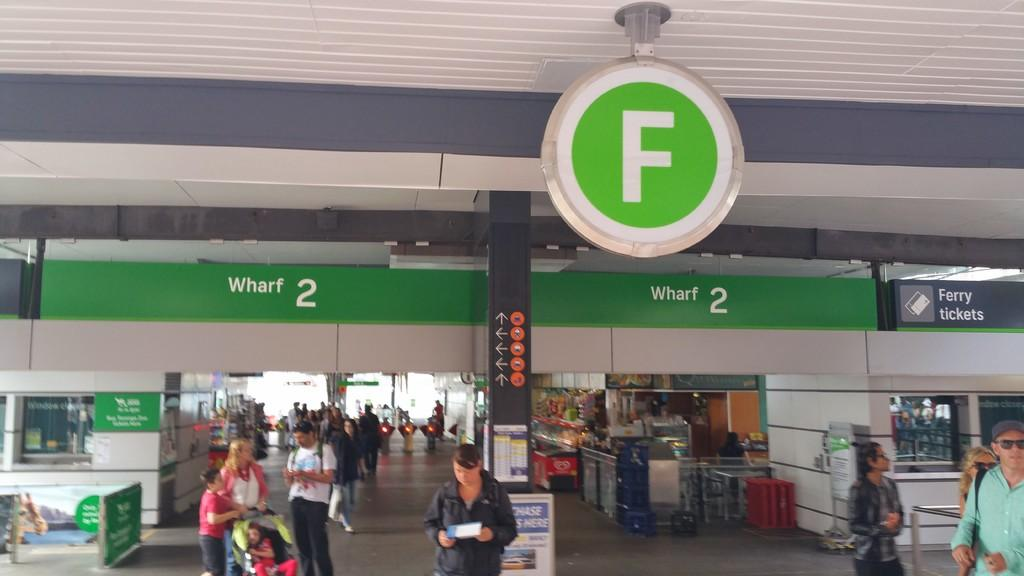<image>
Present a compact description of the photo's key features. A terminal with signs for Wharf 2 and arrows 